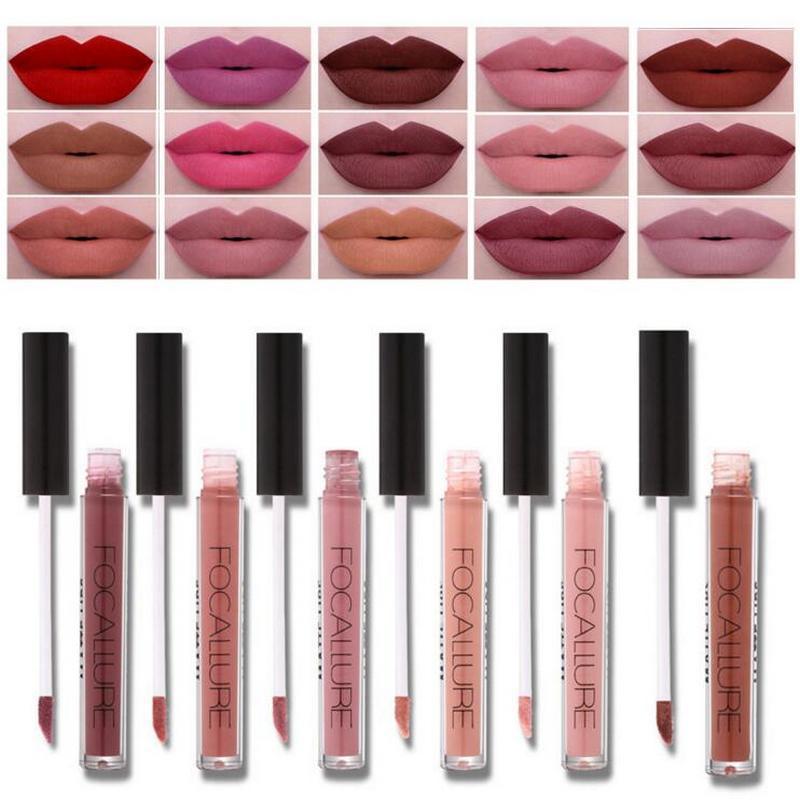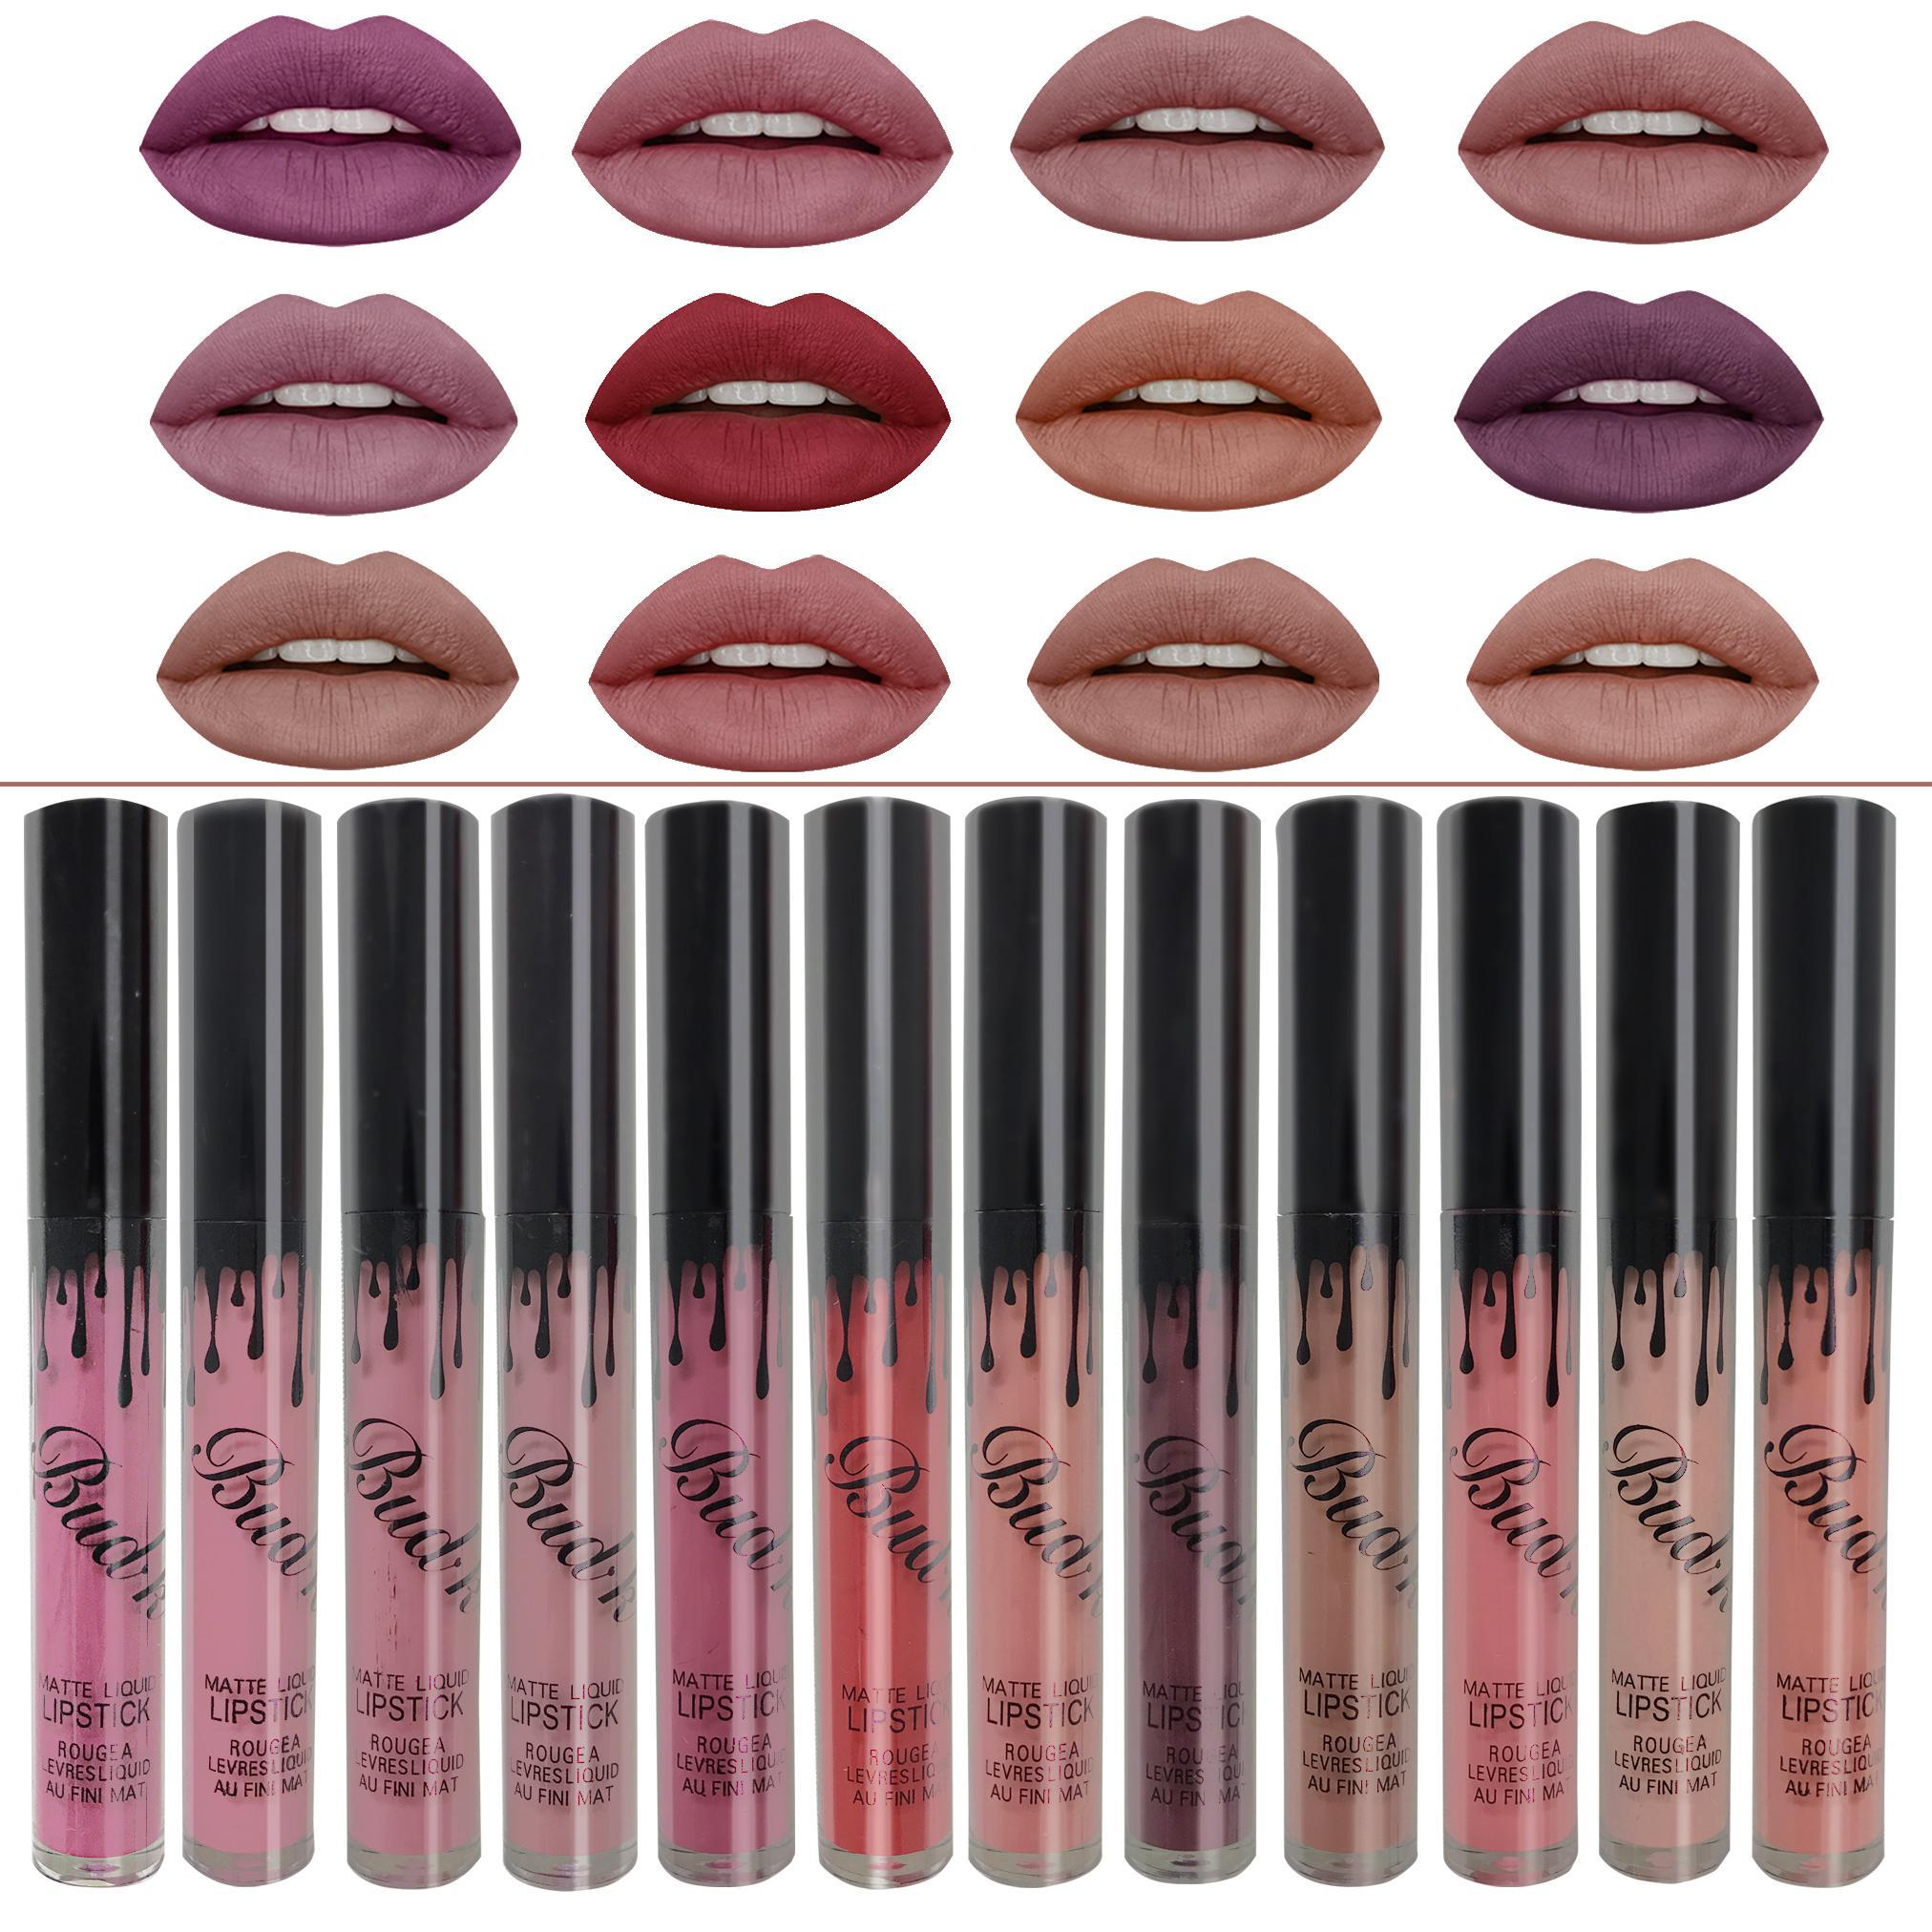The first image is the image on the left, the second image is the image on the right. Analyze the images presented: Is the assertion "At least one of the images shows exactly three mouths." valid? Answer yes or no. No. 